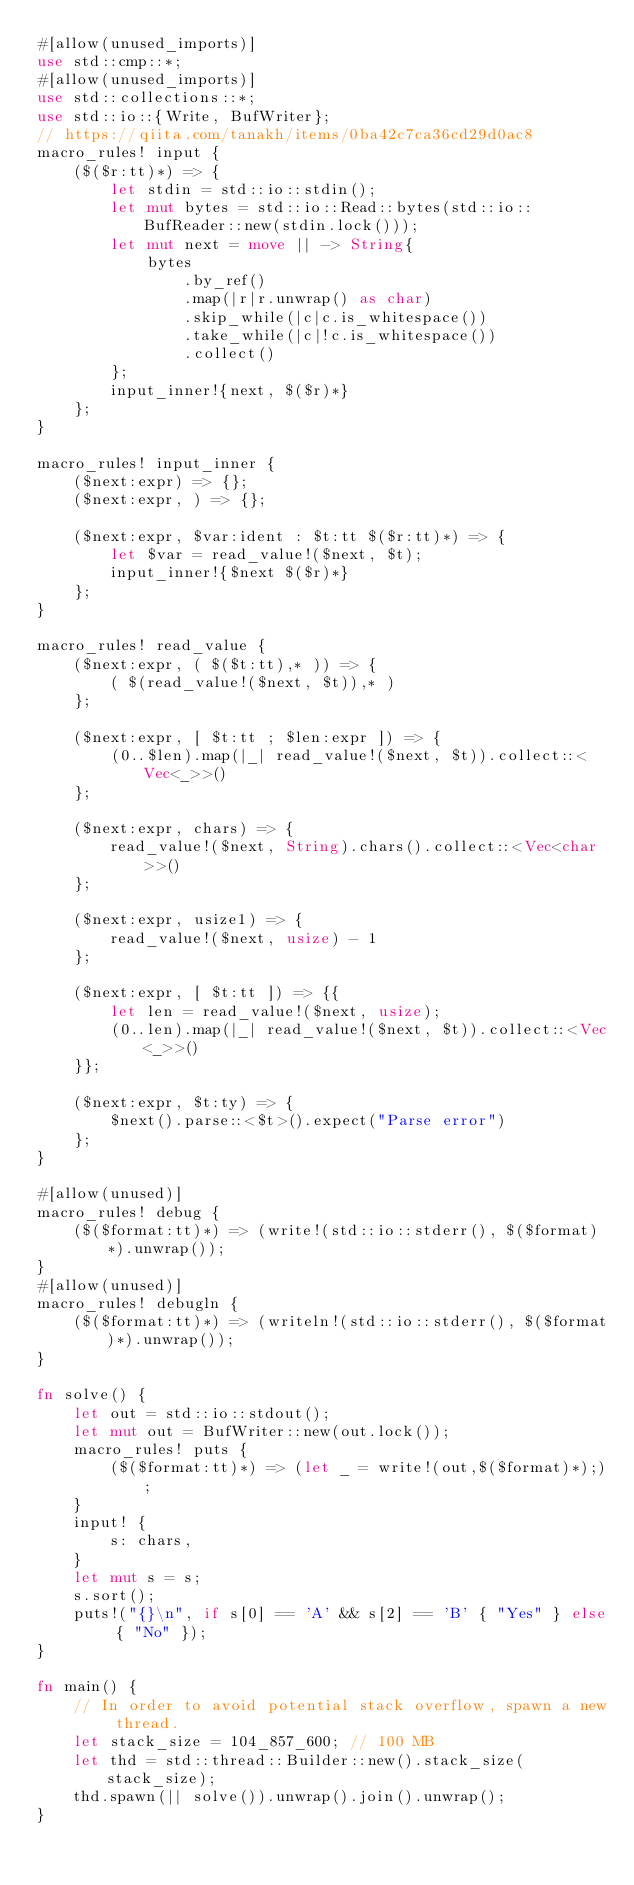<code> <loc_0><loc_0><loc_500><loc_500><_Rust_>#[allow(unused_imports)]
use std::cmp::*;
#[allow(unused_imports)]
use std::collections::*;
use std::io::{Write, BufWriter};
// https://qiita.com/tanakh/items/0ba42c7ca36cd29d0ac8
macro_rules! input {
    ($($r:tt)*) => {
        let stdin = std::io::stdin();
        let mut bytes = std::io::Read::bytes(std::io::BufReader::new(stdin.lock()));
        let mut next = move || -> String{
            bytes
                .by_ref()
                .map(|r|r.unwrap() as char)
                .skip_while(|c|c.is_whitespace())
                .take_while(|c|!c.is_whitespace())
                .collect()
        };
        input_inner!{next, $($r)*}
    };
}

macro_rules! input_inner {
    ($next:expr) => {};
    ($next:expr, ) => {};

    ($next:expr, $var:ident : $t:tt $($r:tt)*) => {
        let $var = read_value!($next, $t);
        input_inner!{$next $($r)*}
    };
}

macro_rules! read_value {
    ($next:expr, ( $($t:tt),* )) => {
        ( $(read_value!($next, $t)),* )
    };

    ($next:expr, [ $t:tt ; $len:expr ]) => {
        (0..$len).map(|_| read_value!($next, $t)).collect::<Vec<_>>()
    };

    ($next:expr, chars) => {
        read_value!($next, String).chars().collect::<Vec<char>>()
    };

    ($next:expr, usize1) => {
        read_value!($next, usize) - 1
    };

    ($next:expr, [ $t:tt ]) => {{
        let len = read_value!($next, usize);
        (0..len).map(|_| read_value!($next, $t)).collect::<Vec<_>>()
    }};

    ($next:expr, $t:ty) => {
        $next().parse::<$t>().expect("Parse error")
    };
}

#[allow(unused)]
macro_rules! debug {
    ($($format:tt)*) => (write!(std::io::stderr(), $($format)*).unwrap());
}
#[allow(unused)]
macro_rules! debugln {
    ($($format:tt)*) => (writeln!(std::io::stderr(), $($format)*).unwrap());
}

fn solve() {
    let out = std::io::stdout();
    let mut out = BufWriter::new(out.lock());
    macro_rules! puts {
        ($($format:tt)*) => (let _ = write!(out,$($format)*););
    }
    input! {
        s: chars,
    }
    let mut s = s;
    s.sort();
    puts!("{}\n", if s[0] == 'A' && s[2] == 'B' { "Yes" } else { "No" });
}

fn main() {
    // In order to avoid potential stack overflow, spawn a new thread.
    let stack_size = 104_857_600; // 100 MB
    let thd = std::thread::Builder::new().stack_size(stack_size);
    thd.spawn(|| solve()).unwrap().join().unwrap();
}
</code> 